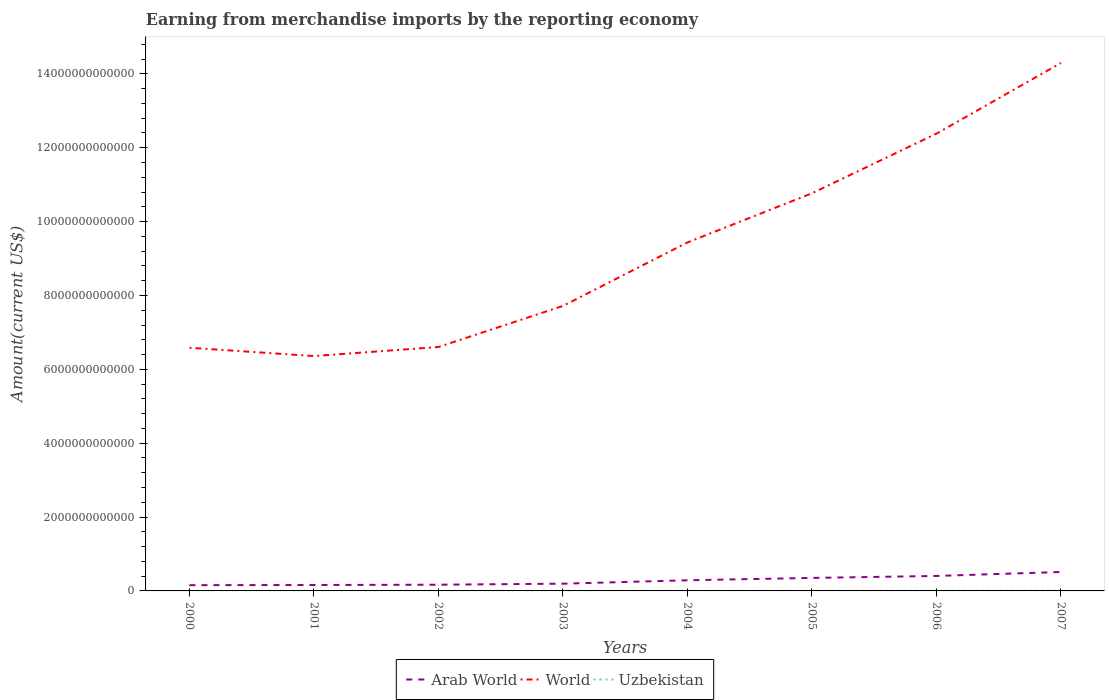How many different coloured lines are there?
Your answer should be very brief. 3. Is the number of lines equal to the number of legend labels?
Make the answer very short. Yes. Across all years, what is the maximum amount earned from merchandise imports in Arab World?
Your answer should be compact. 1.56e+11. In which year was the amount earned from merchandise imports in World maximum?
Provide a succinct answer. 2001. What is the total amount earned from merchandise imports in Uzbekistan in the graph?
Offer a very short reply. -2.01e+09. What is the difference between the highest and the second highest amount earned from merchandise imports in World?
Your answer should be compact. 7.94e+12. What is the difference between the highest and the lowest amount earned from merchandise imports in Uzbekistan?
Offer a very short reply. 3. Is the amount earned from merchandise imports in World strictly greater than the amount earned from merchandise imports in Uzbekistan over the years?
Ensure brevity in your answer.  No. How many lines are there?
Your answer should be compact. 3. How many years are there in the graph?
Provide a succinct answer. 8. What is the difference between two consecutive major ticks on the Y-axis?
Offer a terse response. 2.00e+12. Where does the legend appear in the graph?
Your answer should be compact. Bottom center. What is the title of the graph?
Make the answer very short. Earning from merchandise imports by the reporting economy. What is the label or title of the X-axis?
Make the answer very short. Years. What is the label or title of the Y-axis?
Your answer should be compact. Amount(current US$). What is the Amount(current US$) of Arab World in 2000?
Offer a terse response. 1.56e+11. What is the Amount(current US$) of World in 2000?
Make the answer very short. 6.58e+12. What is the Amount(current US$) in Uzbekistan in 2000?
Your answer should be compact. 2.07e+09. What is the Amount(current US$) in Arab World in 2001?
Offer a terse response. 1.60e+11. What is the Amount(current US$) in World in 2001?
Offer a very short reply. 6.36e+12. What is the Amount(current US$) of Uzbekistan in 2001?
Keep it short and to the point. 2.29e+09. What is the Amount(current US$) of Arab World in 2002?
Make the answer very short. 1.68e+11. What is the Amount(current US$) of World in 2002?
Your answer should be very brief. 6.60e+12. What is the Amount(current US$) of Uzbekistan in 2002?
Make the answer very short. 2.08e+09. What is the Amount(current US$) of Arab World in 2003?
Ensure brevity in your answer.  1.96e+11. What is the Amount(current US$) of World in 2003?
Offer a terse response. 7.72e+12. What is the Amount(current US$) in Uzbekistan in 2003?
Provide a short and direct response. 2.48e+09. What is the Amount(current US$) of Arab World in 2004?
Provide a short and direct response. 2.88e+11. What is the Amount(current US$) in World in 2004?
Ensure brevity in your answer.  9.44e+12. What is the Amount(current US$) of Uzbekistan in 2004?
Your answer should be very brief. 3.16e+09. What is the Amount(current US$) in Arab World in 2005?
Ensure brevity in your answer.  3.52e+11. What is the Amount(current US$) in World in 2005?
Ensure brevity in your answer.  1.08e+13. What is the Amount(current US$) in Uzbekistan in 2005?
Provide a short and direct response. 3.57e+09. What is the Amount(current US$) in Arab World in 2006?
Provide a succinct answer. 4.05e+11. What is the Amount(current US$) of World in 2006?
Make the answer very short. 1.24e+13. What is the Amount(current US$) of Uzbekistan in 2006?
Offer a terse response. 4.49e+09. What is the Amount(current US$) in Arab World in 2007?
Offer a terse response. 5.13e+11. What is the Amount(current US$) of World in 2007?
Give a very brief answer. 1.43e+13. What is the Amount(current US$) of Uzbekistan in 2007?
Offer a very short reply. 7.03e+09. Across all years, what is the maximum Amount(current US$) of Arab World?
Keep it short and to the point. 5.13e+11. Across all years, what is the maximum Amount(current US$) of World?
Keep it short and to the point. 1.43e+13. Across all years, what is the maximum Amount(current US$) of Uzbekistan?
Your answer should be compact. 7.03e+09. Across all years, what is the minimum Amount(current US$) of Arab World?
Offer a terse response. 1.56e+11. Across all years, what is the minimum Amount(current US$) in World?
Provide a succinct answer. 6.36e+12. Across all years, what is the minimum Amount(current US$) of Uzbekistan?
Give a very brief answer. 2.07e+09. What is the total Amount(current US$) in Arab World in the graph?
Give a very brief answer. 2.24e+12. What is the total Amount(current US$) in World in the graph?
Your response must be concise. 7.41e+13. What is the total Amount(current US$) of Uzbekistan in the graph?
Keep it short and to the point. 2.72e+1. What is the difference between the Amount(current US$) of Arab World in 2000 and that in 2001?
Make the answer very short. -4.48e+09. What is the difference between the Amount(current US$) of World in 2000 and that in 2001?
Give a very brief answer. 2.25e+11. What is the difference between the Amount(current US$) of Uzbekistan in 2000 and that in 2001?
Offer a terse response. -2.17e+08. What is the difference between the Amount(current US$) of Arab World in 2000 and that in 2002?
Your answer should be compact. -1.27e+1. What is the difference between the Amount(current US$) of World in 2000 and that in 2002?
Offer a very short reply. -2.01e+1. What is the difference between the Amount(current US$) in Uzbekistan in 2000 and that in 2002?
Give a very brief answer. -3.77e+06. What is the difference between the Amount(current US$) of Arab World in 2000 and that in 2003?
Your answer should be compact. -4.04e+1. What is the difference between the Amount(current US$) of World in 2000 and that in 2003?
Make the answer very short. -1.13e+12. What is the difference between the Amount(current US$) in Uzbekistan in 2000 and that in 2003?
Provide a short and direct response. -4.13e+08. What is the difference between the Amount(current US$) in Arab World in 2000 and that in 2004?
Give a very brief answer. -1.32e+11. What is the difference between the Amount(current US$) in World in 2000 and that in 2004?
Provide a succinct answer. -2.85e+12. What is the difference between the Amount(current US$) of Uzbekistan in 2000 and that in 2004?
Your response must be concise. -1.09e+09. What is the difference between the Amount(current US$) in Arab World in 2000 and that in 2005?
Make the answer very short. -1.96e+11. What is the difference between the Amount(current US$) in World in 2000 and that in 2005?
Your answer should be very brief. -4.18e+12. What is the difference between the Amount(current US$) in Uzbekistan in 2000 and that in 2005?
Your answer should be compact. -1.50e+09. What is the difference between the Amount(current US$) of Arab World in 2000 and that in 2006?
Offer a very short reply. -2.50e+11. What is the difference between the Amount(current US$) of World in 2000 and that in 2006?
Your response must be concise. -5.80e+12. What is the difference between the Amount(current US$) in Uzbekistan in 2000 and that in 2006?
Provide a short and direct response. -2.42e+09. What is the difference between the Amount(current US$) of Arab World in 2000 and that in 2007?
Offer a very short reply. -3.57e+11. What is the difference between the Amount(current US$) of World in 2000 and that in 2007?
Your answer should be very brief. -7.71e+12. What is the difference between the Amount(current US$) of Uzbekistan in 2000 and that in 2007?
Offer a terse response. -4.96e+09. What is the difference between the Amount(current US$) in Arab World in 2001 and that in 2002?
Your answer should be very brief. -8.18e+09. What is the difference between the Amount(current US$) of World in 2001 and that in 2002?
Keep it short and to the point. -2.45e+11. What is the difference between the Amount(current US$) of Uzbekistan in 2001 and that in 2002?
Keep it short and to the point. 2.13e+08. What is the difference between the Amount(current US$) in Arab World in 2001 and that in 2003?
Give a very brief answer. -3.59e+1. What is the difference between the Amount(current US$) of World in 2001 and that in 2003?
Ensure brevity in your answer.  -1.36e+12. What is the difference between the Amount(current US$) in Uzbekistan in 2001 and that in 2003?
Make the answer very short. -1.96e+08. What is the difference between the Amount(current US$) of Arab World in 2001 and that in 2004?
Your answer should be very brief. -1.28e+11. What is the difference between the Amount(current US$) of World in 2001 and that in 2004?
Provide a short and direct response. -3.08e+12. What is the difference between the Amount(current US$) in Uzbekistan in 2001 and that in 2004?
Offer a very short reply. -8.74e+08. What is the difference between the Amount(current US$) in Arab World in 2001 and that in 2005?
Keep it short and to the point. -1.92e+11. What is the difference between the Amount(current US$) in World in 2001 and that in 2005?
Give a very brief answer. -4.41e+12. What is the difference between the Amount(current US$) of Uzbekistan in 2001 and that in 2005?
Make the answer very short. -1.28e+09. What is the difference between the Amount(current US$) of Arab World in 2001 and that in 2006?
Ensure brevity in your answer.  -2.45e+11. What is the difference between the Amount(current US$) of World in 2001 and that in 2006?
Your response must be concise. -6.02e+12. What is the difference between the Amount(current US$) in Uzbekistan in 2001 and that in 2006?
Provide a short and direct response. -2.20e+09. What is the difference between the Amount(current US$) of Arab World in 2001 and that in 2007?
Offer a very short reply. -3.53e+11. What is the difference between the Amount(current US$) of World in 2001 and that in 2007?
Your response must be concise. -7.94e+12. What is the difference between the Amount(current US$) of Uzbekistan in 2001 and that in 2007?
Keep it short and to the point. -4.74e+09. What is the difference between the Amount(current US$) in Arab World in 2002 and that in 2003?
Keep it short and to the point. -2.78e+1. What is the difference between the Amount(current US$) of World in 2002 and that in 2003?
Keep it short and to the point. -1.11e+12. What is the difference between the Amount(current US$) in Uzbekistan in 2002 and that in 2003?
Ensure brevity in your answer.  -4.09e+08. What is the difference between the Amount(current US$) of Arab World in 2002 and that in 2004?
Give a very brief answer. -1.20e+11. What is the difference between the Amount(current US$) in World in 2002 and that in 2004?
Your answer should be very brief. -2.83e+12. What is the difference between the Amount(current US$) in Uzbekistan in 2002 and that in 2004?
Your response must be concise. -1.09e+09. What is the difference between the Amount(current US$) in Arab World in 2002 and that in 2005?
Your answer should be compact. -1.84e+11. What is the difference between the Amount(current US$) of World in 2002 and that in 2005?
Your answer should be compact. -4.16e+12. What is the difference between the Amount(current US$) of Uzbekistan in 2002 and that in 2005?
Offer a very short reply. -1.49e+09. What is the difference between the Amount(current US$) in Arab World in 2002 and that in 2006?
Provide a succinct answer. -2.37e+11. What is the difference between the Amount(current US$) of World in 2002 and that in 2006?
Make the answer very short. -5.78e+12. What is the difference between the Amount(current US$) in Uzbekistan in 2002 and that in 2006?
Make the answer very short. -2.42e+09. What is the difference between the Amount(current US$) of Arab World in 2002 and that in 2007?
Your answer should be very brief. -3.45e+11. What is the difference between the Amount(current US$) in World in 2002 and that in 2007?
Make the answer very short. -7.69e+12. What is the difference between the Amount(current US$) in Uzbekistan in 2002 and that in 2007?
Keep it short and to the point. -4.95e+09. What is the difference between the Amount(current US$) in Arab World in 2003 and that in 2004?
Make the answer very short. -9.20e+1. What is the difference between the Amount(current US$) of World in 2003 and that in 2004?
Offer a terse response. -1.72e+12. What is the difference between the Amount(current US$) of Uzbekistan in 2003 and that in 2004?
Your answer should be very brief. -6.78e+08. What is the difference between the Amount(current US$) in Arab World in 2003 and that in 2005?
Your response must be concise. -1.56e+11. What is the difference between the Amount(current US$) in World in 2003 and that in 2005?
Keep it short and to the point. -3.05e+12. What is the difference between the Amount(current US$) of Uzbekistan in 2003 and that in 2005?
Provide a succinct answer. -1.08e+09. What is the difference between the Amount(current US$) in Arab World in 2003 and that in 2006?
Your answer should be compact. -2.09e+11. What is the difference between the Amount(current US$) of World in 2003 and that in 2006?
Offer a terse response. -4.66e+12. What is the difference between the Amount(current US$) in Uzbekistan in 2003 and that in 2006?
Offer a terse response. -2.01e+09. What is the difference between the Amount(current US$) of Arab World in 2003 and that in 2007?
Your response must be concise. -3.17e+11. What is the difference between the Amount(current US$) of World in 2003 and that in 2007?
Provide a succinct answer. -6.58e+12. What is the difference between the Amount(current US$) of Uzbekistan in 2003 and that in 2007?
Ensure brevity in your answer.  -4.55e+09. What is the difference between the Amount(current US$) in Arab World in 2004 and that in 2005?
Offer a terse response. -6.41e+1. What is the difference between the Amount(current US$) of World in 2004 and that in 2005?
Give a very brief answer. -1.33e+12. What is the difference between the Amount(current US$) in Uzbekistan in 2004 and that in 2005?
Offer a terse response. -4.07e+08. What is the difference between the Amount(current US$) in Arab World in 2004 and that in 2006?
Keep it short and to the point. -1.17e+11. What is the difference between the Amount(current US$) of World in 2004 and that in 2006?
Provide a succinct answer. -2.95e+12. What is the difference between the Amount(current US$) of Uzbekistan in 2004 and that in 2006?
Give a very brief answer. -1.33e+09. What is the difference between the Amount(current US$) of Arab World in 2004 and that in 2007?
Provide a succinct answer. -2.25e+11. What is the difference between the Amount(current US$) in World in 2004 and that in 2007?
Offer a terse response. -4.86e+12. What is the difference between the Amount(current US$) of Uzbekistan in 2004 and that in 2007?
Provide a short and direct response. -3.87e+09. What is the difference between the Amount(current US$) of Arab World in 2005 and that in 2006?
Keep it short and to the point. -5.33e+1. What is the difference between the Amount(current US$) in World in 2005 and that in 2006?
Your answer should be compact. -1.62e+12. What is the difference between the Amount(current US$) in Uzbekistan in 2005 and that in 2006?
Provide a succinct answer. -9.23e+08. What is the difference between the Amount(current US$) of Arab World in 2005 and that in 2007?
Ensure brevity in your answer.  -1.61e+11. What is the difference between the Amount(current US$) of World in 2005 and that in 2007?
Your response must be concise. -3.53e+12. What is the difference between the Amount(current US$) in Uzbekistan in 2005 and that in 2007?
Your answer should be compact. -3.46e+09. What is the difference between the Amount(current US$) of Arab World in 2006 and that in 2007?
Provide a short and direct response. -1.08e+11. What is the difference between the Amount(current US$) of World in 2006 and that in 2007?
Give a very brief answer. -1.91e+12. What is the difference between the Amount(current US$) of Uzbekistan in 2006 and that in 2007?
Your response must be concise. -2.54e+09. What is the difference between the Amount(current US$) in Arab World in 2000 and the Amount(current US$) in World in 2001?
Offer a terse response. -6.20e+12. What is the difference between the Amount(current US$) in Arab World in 2000 and the Amount(current US$) in Uzbekistan in 2001?
Offer a terse response. 1.53e+11. What is the difference between the Amount(current US$) in World in 2000 and the Amount(current US$) in Uzbekistan in 2001?
Make the answer very short. 6.58e+12. What is the difference between the Amount(current US$) in Arab World in 2000 and the Amount(current US$) in World in 2002?
Give a very brief answer. -6.45e+12. What is the difference between the Amount(current US$) in Arab World in 2000 and the Amount(current US$) in Uzbekistan in 2002?
Ensure brevity in your answer.  1.54e+11. What is the difference between the Amount(current US$) in World in 2000 and the Amount(current US$) in Uzbekistan in 2002?
Your answer should be compact. 6.58e+12. What is the difference between the Amount(current US$) of Arab World in 2000 and the Amount(current US$) of World in 2003?
Make the answer very short. -7.56e+12. What is the difference between the Amount(current US$) in Arab World in 2000 and the Amount(current US$) in Uzbekistan in 2003?
Provide a succinct answer. 1.53e+11. What is the difference between the Amount(current US$) of World in 2000 and the Amount(current US$) of Uzbekistan in 2003?
Give a very brief answer. 6.58e+12. What is the difference between the Amount(current US$) in Arab World in 2000 and the Amount(current US$) in World in 2004?
Make the answer very short. -9.28e+12. What is the difference between the Amount(current US$) of Arab World in 2000 and the Amount(current US$) of Uzbekistan in 2004?
Make the answer very short. 1.52e+11. What is the difference between the Amount(current US$) of World in 2000 and the Amount(current US$) of Uzbekistan in 2004?
Offer a terse response. 6.58e+12. What is the difference between the Amount(current US$) in Arab World in 2000 and the Amount(current US$) in World in 2005?
Your answer should be very brief. -1.06e+13. What is the difference between the Amount(current US$) in Arab World in 2000 and the Amount(current US$) in Uzbekistan in 2005?
Ensure brevity in your answer.  1.52e+11. What is the difference between the Amount(current US$) of World in 2000 and the Amount(current US$) of Uzbekistan in 2005?
Keep it short and to the point. 6.58e+12. What is the difference between the Amount(current US$) of Arab World in 2000 and the Amount(current US$) of World in 2006?
Ensure brevity in your answer.  -1.22e+13. What is the difference between the Amount(current US$) in Arab World in 2000 and the Amount(current US$) in Uzbekistan in 2006?
Provide a succinct answer. 1.51e+11. What is the difference between the Amount(current US$) in World in 2000 and the Amount(current US$) in Uzbekistan in 2006?
Offer a very short reply. 6.58e+12. What is the difference between the Amount(current US$) in Arab World in 2000 and the Amount(current US$) in World in 2007?
Give a very brief answer. -1.41e+13. What is the difference between the Amount(current US$) in Arab World in 2000 and the Amount(current US$) in Uzbekistan in 2007?
Give a very brief answer. 1.49e+11. What is the difference between the Amount(current US$) in World in 2000 and the Amount(current US$) in Uzbekistan in 2007?
Your answer should be compact. 6.58e+12. What is the difference between the Amount(current US$) of Arab World in 2001 and the Amount(current US$) of World in 2002?
Offer a terse response. -6.44e+12. What is the difference between the Amount(current US$) in Arab World in 2001 and the Amount(current US$) in Uzbekistan in 2002?
Provide a short and direct response. 1.58e+11. What is the difference between the Amount(current US$) in World in 2001 and the Amount(current US$) in Uzbekistan in 2002?
Your response must be concise. 6.36e+12. What is the difference between the Amount(current US$) of Arab World in 2001 and the Amount(current US$) of World in 2003?
Offer a very short reply. -7.56e+12. What is the difference between the Amount(current US$) in Arab World in 2001 and the Amount(current US$) in Uzbekistan in 2003?
Provide a succinct answer. 1.58e+11. What is the difference between the Amount(current US$) in World in 2001 and the Amount(current US$) in Uzbekistan in 2003?
Offer a very short reply. 6.36e+12. What is the difference between the Amount(current US$) of Arab World in 2001 and the Amount(current US$) of World in 2004?
Ensure brevity in your answer.  -9.28e+12. What is the difference between the Amount(current US$) in Arab World in 2001 and the Amount(current US$) in Uzbekistan in 2004?
Your answer should be very brief. 1.57e+11. What is the difference between the Amount(current US$) in World in 2001 and the Amount(current US$) in Uzbekistan in 2004?
Provide a succinct answer. 6.36e+12. What is the difference between the Amount(current US$) in Arab World in 2001 and the Amount(current US$) in World in 2005?
Ensure brevity in your answer.  -1.06e+13. What is the difference between the Amount(current US$) of Arab World in 2001 and the Amount(current US$) of Uzbekistan in 2005?
Your answer should be very brief. 1.57e+11. What is the difference between the Amount(current US$) of World in 2001 and the Amount(current US$) of Uzbekistan in 2005?
Provide a succinct answer. 6.36e+12. What is the difference between the Amount(current US$) in Arab World in 2001 and the Amount(current US$) in World in 2006?
Provide a succinct answer. -1.22e+13. What is the difference between the Amount(current US$) in Arab World in 2001 and the Amount(current US$) in Uzbekistan in 2006?
Offer a very short reply. 1.56e+11. What is the difference between the Amount(current US$) of World in 2001 and the Amount(current US$) of Uzbekistan in 2006?
Provide a succinct answer. 6.35e+12. What is the difference between the Amount(current US$) in Arab World in 2001 and the Amount(current US$) in World in 2007?
Provide a short and direct response. -1.41e+13. What is the difference between the Amount(current US$) of Arab World in 2001 and the Amount(current US$) of Uzbekistan in 2007?
Offer a terse response. 1.53e+11. What is the difference between the Amount(current US$) of World in 2001 and the Amount(current US$) of Uzbekistan in 2007?
Your answer should be compact. 6.35e+12. What is the difference between the Amount(current US$) in Arab World in 2002 and the Amount(current US$) in World in 2003?
Your answer should be very brief. -7.55e+12. What is the difference between the Amount(current US$) in Arab World in 2002 and the Amount(current US$) in Uzbekistan in 2003?
Provide a short and direct response. 1.66e+11. What is the difference between the Amount(current US$) of World in 2002 and the Amount(current US$) of Uzbekistan in 2003?
Provide a succinct answer. 6.60e+12. What is the difference between the Amount(current US$) in Arab World in 2002 and the Amount(current US$) in World in 2004?
Make the answer very short. -9.27e+12. What is the difference between the Amount(current US$) in Arab World in 2002 and the Amount(current US$) in Uzbekistan in 2004?
Ensure brevity in your answer.  1.65e+11. What is the difference between the Amount(current US$) of World in 2002 and the Amount(current US$) of Uzbekistan in 2004?
Offer a terse response. 6.60e+12. What is the difference between the Amount(current US$) of Arab World in 2002 and the Amount(current US$) of World in 2005?
Provide a short and direct response. -1.06e+13. What is the difference between the Amount(current US$) of Arab World in 2002 and the Amount(current US$) of Uzbekistan in 2005?
Provide a succinct answer. 1.65e+11. What is the difference between the Amount(current US$) in World in 2002 and the Amount(current US$) in Uzbekistan in 2005?
Ensure brevity in your answer.  6.60e+12. What is the difference between the Amount(current US$) in Arab World in 2002 and the Amount(current US$) in World in 2006?
Provide a short and direct response. -1.22e+13. What is the difference between the Amount(current US$) in Arab World in 2002 and the Amount(current US$) in Uzbekistan in 2006?
Make the answer very short. 1.64e+11. What is the difference between the Amount(current US$) of World in 2002 and the Amount(current US$) of Uzbekistan in 2006?
Provide a short and direct response. 6.60e+12. What is the difference between the Amount(current US$) of Arab World in 2002 and the Amount(current US$) of World in 2007?
Your response must be concise. -1.41e+13. What is the difference between the Amount(current US$) in Arab World in 2002 and the Amount(current US$) in Uzbekistan in 2007?
Make the answer very short. 1.61e+11. What is the difference between the Amount(current US$) in World in 2002 and the Amount(current US$) in Uzbekistan in 2007?
Your response must be concise. 6.60e+12. What is the difference between the Amount(current US$) of Arab World in 2003 and the Amount(current US$) of World in 2004?
Keep it short and to the point. -9.24e+12. What is the difference between the Amount(current US$) in Arab World in 2003 and the Amount(current US$) in Uzbekistan in 2004?
Your answer should be very brief. 1.93e+11. What is the difference between the Amount(current US$) of World in 2003 and the Amount(current US$) of Uzbekistan in 2004?
Keep it short and to the point. 7.71e+12. What is the difference between the Amount(current US$) in Arab World in 2003 and the Amount(current US$) in World in 2005?
Your response must be concise. -1.06e+13. What is the difference between the Amount(current US$) of Arab World in 2003 and the Amount(current US$) of Uzbekistan in 2005?
Offer a very short reply. 1.93e+11. What is the difference between the Amount(current US$) in World in 2003 and the Amount(current US$) in Uzbekistan in 2005?
Your response must be concise. 7.71e+12. What is the difference between the Amount(current US$) in Arab World in 2003 and the Amount(current US$) in World in 2006?
Your answer should be compact. -1.22e+13. What is the difference between the Amount(current US$) of Arab World in 2003 and the Amount(current US$) of Uzbekistan in 2006?
Give a very brief answer. 1.92e+11. What is the difference between the Amount(current US$) of World in 2003 and the Amount(current US$) of Uzbekistan in 2006?
Keep it short and to the point. 7.71e+12. What is the difference between the Amount(current US$) in Arab World in 2003 and the Amount(current US$) in World in 2007?
Ensure brevity in your answer.  -1.41e+13. What is the difference between the Amount(current US$) in Arab World in 2003 and the Amount(current US$) in Uzbekistan in 2007?
Your answer should be very brief. 1.89e+11. What is the difference between the Amount(current US$) of World in 2003 and the Amount(current US$) of Uzbekistan in 2007?
Your response must be concise. 7.71e+12. What is the difference between the Amount(current US$) of Arab World in 2004 and the Amount(current US$) of World in 2005?
Your response must be concise. -1.05e+13. What is the difference between the Amount(current US$) in Arab World in 2004 and the Amount(current US$) in Uzbekistan in 2005?
Give a very brief answer. 2.84e+11. What is the difference between the Amount(current US$) of World in 2004 and the Amount(current US$) of Uzbekistan in 2005?
Provide a short and direct response. 9.43e+12. What is the difference between the Amount(current US$) of Arab World in 2004 and the Amount(current US$) of World in 2006?
Ensure brevity in your answer.  -1.21e+13. What is the difference between the Amount(current US$) of Arab World in 2004 and the Amount(current US$) of Uzbekistan in 2006?
Provide a short and direct response. 2.84e+11. What is the difference between the Amount(current US$) in World in 2004 and the Amount(current US$) in Uzbekistan in 2006?
Offer a terse response. 9.43e+12. What is the difference between the Amount(current US$) of Arab World in 2004 and the Amount(current US$) of World in 2007?
Keep it short and to the point. -1.40e+13. What is the difference between the Amount(current US$) of Arab World in 2004 and the Amount(current US$) of Uzbekistan in 2007?
Provide a succinct answer. 2.81e+11. What is the difference between the Amount(current US$) in World in 2004 and the Amount(current US$) in Uzbekistan in 2007?
Offer a terse response. 9.43e+12. What is the difference between the Amount(current US$) in Arab World in 2005 and the Amount(current US$) in World in 2006?
Keep it short and to the point. -1.20e+13. What is the difference between the Amount(current US$) in Arab World in 2005 and the Amount(current US$) in Uzbekistan in 2006?
Your response must be concise. 3.48e+11. What is the difference between the Amount(current US$) of World in 2005 and the Amount(current US$) of Uzbekistan in 2006?
Keep it short and to the point. 1.08e+13. What is the difference between the Amount(current US$) in Arab World in 2005 and the Amount(current US$) in World in 2007?
Make the answer very short. -1.39e+13. What is the difference between the Amount(current US$) in Arab World in 2005 and the Amount(current US$) in Uzbekistan in 2007?
Ensure brevity in your answer.  3.45e+11. What is the difference between the Amount(current US$) of World in 2005 and the Amount(current US$) of Uzbekistan in 2007?
Keep it short and to the point. 1.08e+13. What is the difference between the Amount(current US$) in Arab World in 2006 and the Amount(current US$) in World in 2007?
Provide a short and direct response. -1.39e+13. What is the difference between the Amount(current US$) of Arab World in 2006 and the Amount(current US$) of Uzbekistan in 2007?
Offer a terse response. 3.98e+11. What is the difference between the Amount(current US$) in World in 2006 and the Amount(current US$) in Uzbekistan in 2007?
Offer a very short reply. 1.24e+13. What is the average Amount(current US$) in Arab World per year?
Keep it short and to the point. 2.80e+11. What is the average Amount(current US$) of World per year?
Offer a very short reply. 9.27e+12. What is the average Amount(current US$) in Uzbekistan per year?
Offer a terse response. 3.40e+09. In the year 2000, what is the difference between the Amount(current US$) in Arab World and Amount(current US$) in World?
Offer a very short reply. -6.43e+12. In the year 2000, what is the difference between the Amount(current US$) in Arab World and Amount(current US$) in Uzbekistan?
Offer a very short reply. 1.54e+11. In the year 2000, what is the difference between the Amount(current US$) of World and Amount(current US$) of Uzbekistan?
Offer a very short reply. 6.58e+12. In the year 2001, what is the difference between the Amount(current US$) of Arab World and Amount(current US$) of World?
Offer a terse response. -6.20e+12. In the year 2001, what is the difference between the Amount(current US$) of Arab World and Amount(current US$) of Uzbekistan?
Offer a very short reply. 1.58e+11. In the year 2001, what is the difference between the Amount(current US$) of World and Amount(current US$) of Uzbekistan?
Your response must be concise. 6.36e+12. In the year 2002, what is the difference between the Amount(current US$) of Arab World and Amount(current US$) of World?
Give a very brief answer. -6.44e+12. In the year 2002, what is the difference between the Amount(current US$) of Arab World and Amount(current US$) of Uzbekistan?
Provide a succinct answer. 1.66e+11. In the year 2002, what is the difference between the Amount(current US$) of World and Amount(current US$) of Uzbekistan?
Give a very brief answer. 6.60e+12. In the year 2003, what is the difference between the Amount(current US$) of Arab World and Amount(current US$) of World?
Offer a very short reply. -7.52e+12. In the year 2003, what is the difference between the Amount(current US$) in Arab World and Amount(current US$) in Uzbekistan?
Your response must be concise. 1.94e+11. In the year 2003, what is the difference between the Amount(current US$) of World and Amount(current US$) of Uzbekistan?
Offer a terse response. 7.71e+12. In the year 2004, what is the difference between the Amount(current US$) in Arab World and Amount(current US$) in World?
Provide a succinct answer. -9.15e+12. In the year 2004, what is the difference between the Amount(current US$) of Arab World and Amount(current US$) of Uzbekistan?
Your answer should be very brief. 2.85e+11. In the year 2004, what is the difference between the Amount(current US$) of World and Amount(current US$) of Uzbekistan?
Provide a short and direct response. 9.43e+12. In the year 2005, what is the difference between the Amount(current US$) of Arab World and Amount(current US$) of World?
Offer a very short reply. -1.04e+13. In the year 2005, what is the difference between the Amount(current US$) in Arab World and Amount(current US$) in Uzbekistan?
Your answer should be very brief. 3.49e+11. In the year 2005, what is the difference between the Amount(current US$) in World and Amount(current US$) in Uzbekistan?
Make the answer very short. 1.08e+13. In the year 2006, what is the difference between the Amount(current US$) in Arab World and Amount(current US$) in World?
Keep it short and to the point. -1.20e+13. In the year 2006, what is the difference between the Amount(current US$) of Arab World and Amount(current US$) of Uzbekistan?
Your answer should be compact. 4.01e+11. In the year 2006, what is the difference between the Amount(current US$) of World and Amount(current US$) of Uzbekistan?
Your answer should be very brief. 1.24e+13. In the year 2007, what is the difference between the Amount(current US$) of Arab World and Amount(current US$) of World?
Keep it short and to the point. -1.38e+13. In the year 2007, what is the difference between the Amount(current US$) in Arab World and Amount(current US$) in Uzbekistan?
Give a very brief answer. 5.06e+11. In the year 2007, what is the difference between the Amount(current US$) in World and Amount(current US$) in Uzbekistan?
Offer a terse response. 1.43e+13. What is the ratio of the Amount(current US$) of Arab World in 2000 to that in 2001?
Your answer should be very brief. 0.97. What is the ratio of the Amount(current US$) of World in 2000 to that in 2001?
Your response must be concise. 1.04. What is the ratio of the Amount(current US$) in Uzbekistan in 2000 to that in 2001?
Give a very brief answer. 0.91. What is the ratio of the Amount(current US$) of Arab World in 2000 to that in 2002?
Offer a terse response. 0.92. What is the ratio of the Amount(current US$) of World in 2000 to that in 2002?
Your response must be concise. 1. What is the ratio of the Amount(current US$) of Uzbekistan in 2000 to that in 2002?
Make the answer very short. 1. What is the ratio of the Amount(current US$) of Arab World in 2000 to that in 2003?
Keep it short and to the point. 0.79. What is the ratio of the Amount(current US$) in World in 2000 to that in 2003?
Ensure brevity in your answer.  0.85. What is the ratio of the Amount(current US$) in Uzbekistan in 2000 to that in 2003?
Your answer should be compact. 0.83. What is the ratio of the Amount(current US$) in Arab World in 2000 to that in 2004?
Your answer should be compact. 0.54. What is the ratio of the Amount(current US$) in World in 2000 to that in 2004?
Provide a short and direct response. 0.7. What is the ratio of the Amount(current US$) in Uzbekistan in 2000 to that in 2004?
Give a very brief answer. 0.66. What is the ratio of the Amount(current US$) of Arab World in 2000 to that in 2005?
Offer a terse response. 0.44. What is the ratio of the Amount(current US$) of World in 2000 to that in 2005?
Make the answer very short. 0.61. What is the ratio of the Amount(current US$) in Uzbekistan in 2000 to that in 2005?
Provide a short and direct response. 0.58. What is the ratio of the Amount(current US$) of Arab World in 2000 to that in 2006?
Offer a very short reply. 0.38. What is the ratio of the Amount(current US$) in World in 2000 to that in 2006?
Provide a succinct answer. 0.53. What is the ratio of the Amount(current US$) in Uzbekistan in 2000 to that in 2006?
Ensure brevity in your answer.  0.46. What is the ratio of the Amount(current US$) in Arab World in 2000 to that in 2007?
Your answer should be compact. 0.3. What is the ratio of the Amount(current US$) in World in 2000 to that in 2007?
Offer a very short reply. 0.46. What is the ratio of the Amount(current US$) of Uzbekistan in 2000 to that in 2007?
Your answer should be compact. 0.29. What is the ratio of the Amount(current US$) of Arab World in 2001 to that in 2002?
Your response must be concise. 0.95. What is the ratio of the Amount(current US$) of World in 2001 to that in 2002?
Make the answer very short. 0.96. What is the ratio of the Amount(current US$) of Uzbekistan in 2001 to that in 2002?
Provide a short and direct response. 1.1. What is the ratio of the Amount(current US$) in Arab World in 2001 to that in 2003?
Offer a very short reply. 0.82. What is the ratio of the Amount(current US$) in World in 2001 to that in 2003?
Your answer should be compact. 0.82. What is the ratio of the Amount(current US$) of Uzbekistan in 2001 to that in 2003?
Offer a very short reply. 0.92. What is the ratio of the Amount(current US$) of Arab World in 2001 to that in 2004?
Offer a terse response. 0.56. What is the ratio of the Amount(current US$) in World in 2001 to that in 2004?
Your answer should be very brief. 0.67. What is the ratio of the Amount(current US$) in Uzbekistan in 2001 to that in 2004?
Your response must be concise. 0.72. What is the ratio of the Amount(current US$) in Arab World in 2001 to that in 2005?
Provide a short and direct response. 0.45. What is the ratio of the Amount(current US$) of World in 2001 to that in 2005?
Keep it short and to the point. 0.59. What is the ratio of the Amount(current US$) in Uzbekistan in 2001 to that in 2005?
Your response must be concise. 0.64. What is the ratio of the Amount(current US$) of Arab World in 2001 to that in 2006?
Your answer should be compact. 0.39. What is the ratio of the Amount(current US$) of World in 2001 to that in 2006?
Your response must be concise. 0.51. What is the ratio of the Amount(current US$) in Uzbekistan in 2001 to that in 2006?
Keep it short and to the point. 0.51. What is the ratio of the Amount(current US$) of Arab World in 2001 to that in 2007?
Offer a very short reply. 0.31. What is the ratio of the Amount(current US$) of World in 2001 to that in 2007?
Make the answer very short. 0.44. What is the ratio of the Amount(current US$) of Uzbekistan in 2001 to that in 2007?
Your response must be concise. 0.33. What is the ratio of the Amount(current US$) in Arab World in 2002 to that in 2003?
Your answer should be compact. 0.86. What is the ratio of the Amount(current US$) of World in 2002 to that in 2003?
Your response must be concise. 0.86. What is the ratio of the Amount(current US$) of Uzbekistan in 2002 to that in 2003?
Provide a succinct answer. 0.84. What is the ratio of the Amount(current US$) in Arab World in 2002 to that in 2004?
Offer a very short reply. 0.58. What is the ratio of the Amount(current US$) in World in 2002 to that in 2004?
Your answer should be compact. 0.7. What is the ratio of the Amount(current US$) of Uzbekistan in 2002 to that in 2004?
Your response must be concise. 0.66. What is the ratio of the Amount(current US$) of Arab World in 2002 to that in 2005?
Offer a terse response. 0.48. What is the ratio of the Amount(current US$) in World in 2002 to that in 2005?
Provide a succinct answer. 0.61. What is the ratio of the Amount(current US$) of Uzbekistan in 2002 to that in 2005?
Provide a succinct answer. 0.58. What is the ratio of the Amount(current US$) in Arab World in 2002 to that in 2006?
Your answer should be very brief. 0.42. What is the ratio of the Amount(current US$) of World in 2002 to that in 2006?
Offer a terse response. 0.53. What is the ratio of the Amount(current US$) of Uzbekistan in 2002 to that in 2006?
Offer a very short reply. 0.46. What is the ratio of the Amount(current US$) of Arab World in 2002 to that in 2007?
Your response must be concise. 0.33. What is the ratio of the Amount(current US$) of World in 2002 to that in 2007?
Give a very brief answer. 0.46. What is the ratio of the Amount(current US$) of Uzbekistan in 2002 to that in 2007?
Ensure brevity in your answer.  0.3. What is the ratio of the Amount(current US$) of Arab World in 2003 to that in 2004?
Your answer should be very brief. 0.68. What is the ratio of the Amount(current US$) of World in 2003 to that in 2004?
Ensure brevity in your answer.  0.82. What is the ratio of the Amount(current US$) of Uzbekistan in 2003 to that in 2004?
Offer a very short reply. 0.79. What is the ratio of the Amount(current US$) of Arab World in 2003 to that in 2005?
Give a very brief answer. 0.56. What is the ratio of the Amount(current US$) in World in 2003 to that in 2005?
Provide a short and direct response. 0.72. What is the ratio of the Amount(current US$) in Uzbekistan in 2003 to that in 2005?
Your response must be concise. 0.7. What is the ratio of the Amount(current US$) of Arab World in 2003 to that in 2006?
Make the answer very short. 0.48. What is the ratio of the Amount(current US$) in World in 2003 to that in 2006?
Provide a succinct answer. 0.62. What is the ratio of the Amount(current US$) of Uzbekistan in 2003 to that in 2006?
Your response must be concise. 0.55. What is the ratio of the Amount(current US$) in Arab World in 2003 to that in 2007?
Offer a terse response. 0.38. What is the ratio of the Amount(current US$) of World in 2003 to that in 2007?
Ensure brevity in your answer.  0.54. What is the ratio of the Amount(current US$) of Uzbekistan in 2003 to that in 2007?
Offer a terse response. 0.35. What is the ratio of the Amount(current US$) of Arab World in 2004 to that in 2005?
Offer a terse response. 0.82. What is the ratio of the Amount(current US$) in World in 2004 to that in 2005?
Provide a succinct answer. 0.88. What is the ratio of the Amount(current US$) in Uzbekistan in 2004 to that in 2005?
Provide a succinct answer. 0.89. What is the ratio of the Amount(current US$) of Arab World in 2004 to that in 2006?
Provide a succinct answer. 0.71. What is the ratio of the Amount(current US$) of World in 2004 to that in 2006?
Provide a succinct answer. 0.76. What is the ratio of the Amount(current US$) in Uzbekistan in 2004 to that in 2006?
Offer a very short reply. 0.7. What is the ratio of the Amount(current US$) in Arab World in 2004 to that in 2007?
Provide a short and direct response. 0.56. What is the ratio of the Amount(current US$) of World in 2004 to that in 2007?
Provide a short and direct response. 0.66. What is the ratio of the Amount(current US$) in Uzbekistan in 2004 to that in 2007?
Make the answer very short. 0.45. What is the ratio of the Amount(current US$) in Arab World in 2005 to that in 2006?
Make the answer very short. 0.87. What is the ratio of the Amount(current US$) of World in 2005 to that in 2006?
Offer a terse response. 0.87. What is the ratio of the Amount(current US$) of Uzbekistan in 2005 to that in 2006?
Your response must be concise. 0.79. What is the ratio of the Amount(current US$) in Arab World in 2005 to that in 2007?
Ensure brevity in your answer.  0.69. What is the ratio of the Amount(current US$) in World in 2005 to that in 2007?
Your answer should be very brief. 0.75. What is the ratio of the Amount(current US$) in Uzbekistan in 2005 to that in 2007?
Ensure brevity in your answer.  0.51. What is the ratio of the Amount(current US$) of Arab World in 2006 to that in 2007?
Provide a short and direct response. 0.79. What is the ratio of the Amount(current US$) in World in 2006 to that in 2007?
Make the answer very short. 0.87. What is the ratio of the Amount(current US$) in Uzbekistan in 2006 to that in 2007?
Provide a short and direct response. 0.64. What is the difference between the highest and the second highest Amount(current US$) of Arab World?
Make the answer very short. 1.08e+11. What is the difference between the highest and the second highest Amount(current US$) in World?
Give a very brief answer. 1.91e+12. What is the difference between the highest and the second highest Amount(current US$) in Uzbekistan?
Offer a very short reply. 2.54e+09. What is the difference between the highest and the lowest Amount(current US$) in Arab World?
Provide a short and direct response. 3.57e+11. What is the difference between the highest and the lowest Amount(current US$) of World?
Make the answer very short. 7.94e+12. What is the difference between the highest and the lowest Amount(current US$) of Uzbekistan?
Your answer should be compact. 4.96e+09. 